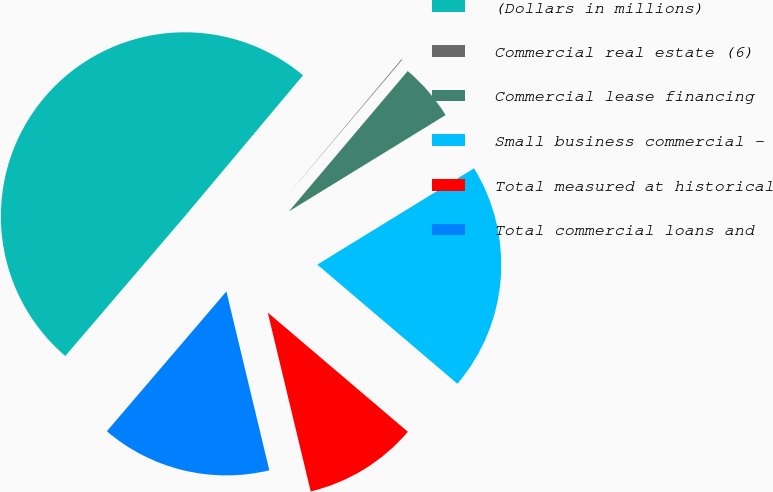Convert chart. <chart><loc_0><loc_0><loc_500><loc_500><pie_chart><fcel>(Dollars in millions)<fcel>Commercial real estate (6)<fcel>Commercial lease financing<fcel>Small business commercial -<fcel>Total measured at historical<fcel>Total commercial loans and<nl><fcel>49.85%<fcel>0.07%<fcel>5.05%<fcel>19.99%<fcel>10.03%<fcel>15.01%<nl></chart> 